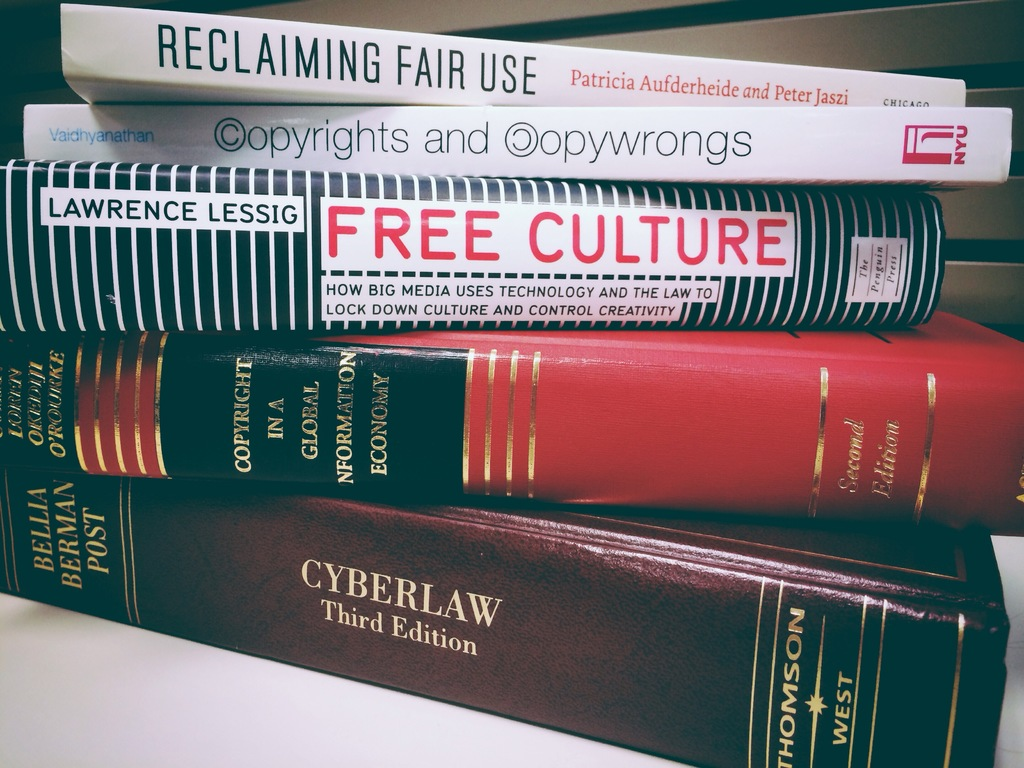Can you explain the contribution of Lawrence Lessig's 'Free Culture' to understanding media and technology? 'Free Culture' by Lawrence Lessig discusses how large media uses technology to control creativity through stringent copyright laws, arguing for more freedom in content creation to foster innovation and access in the digital domain. How has this book influenced contemporary legal or technological discussions? Lessig's work has been pivotal in shaping discussions around copyright reform and digital rights, influencing legislation and policies that seek to balance creator rights with public access. His advocacy for 'Creative Commons' licenses is one notable outcome that has impacted how content is shared and reused online. 